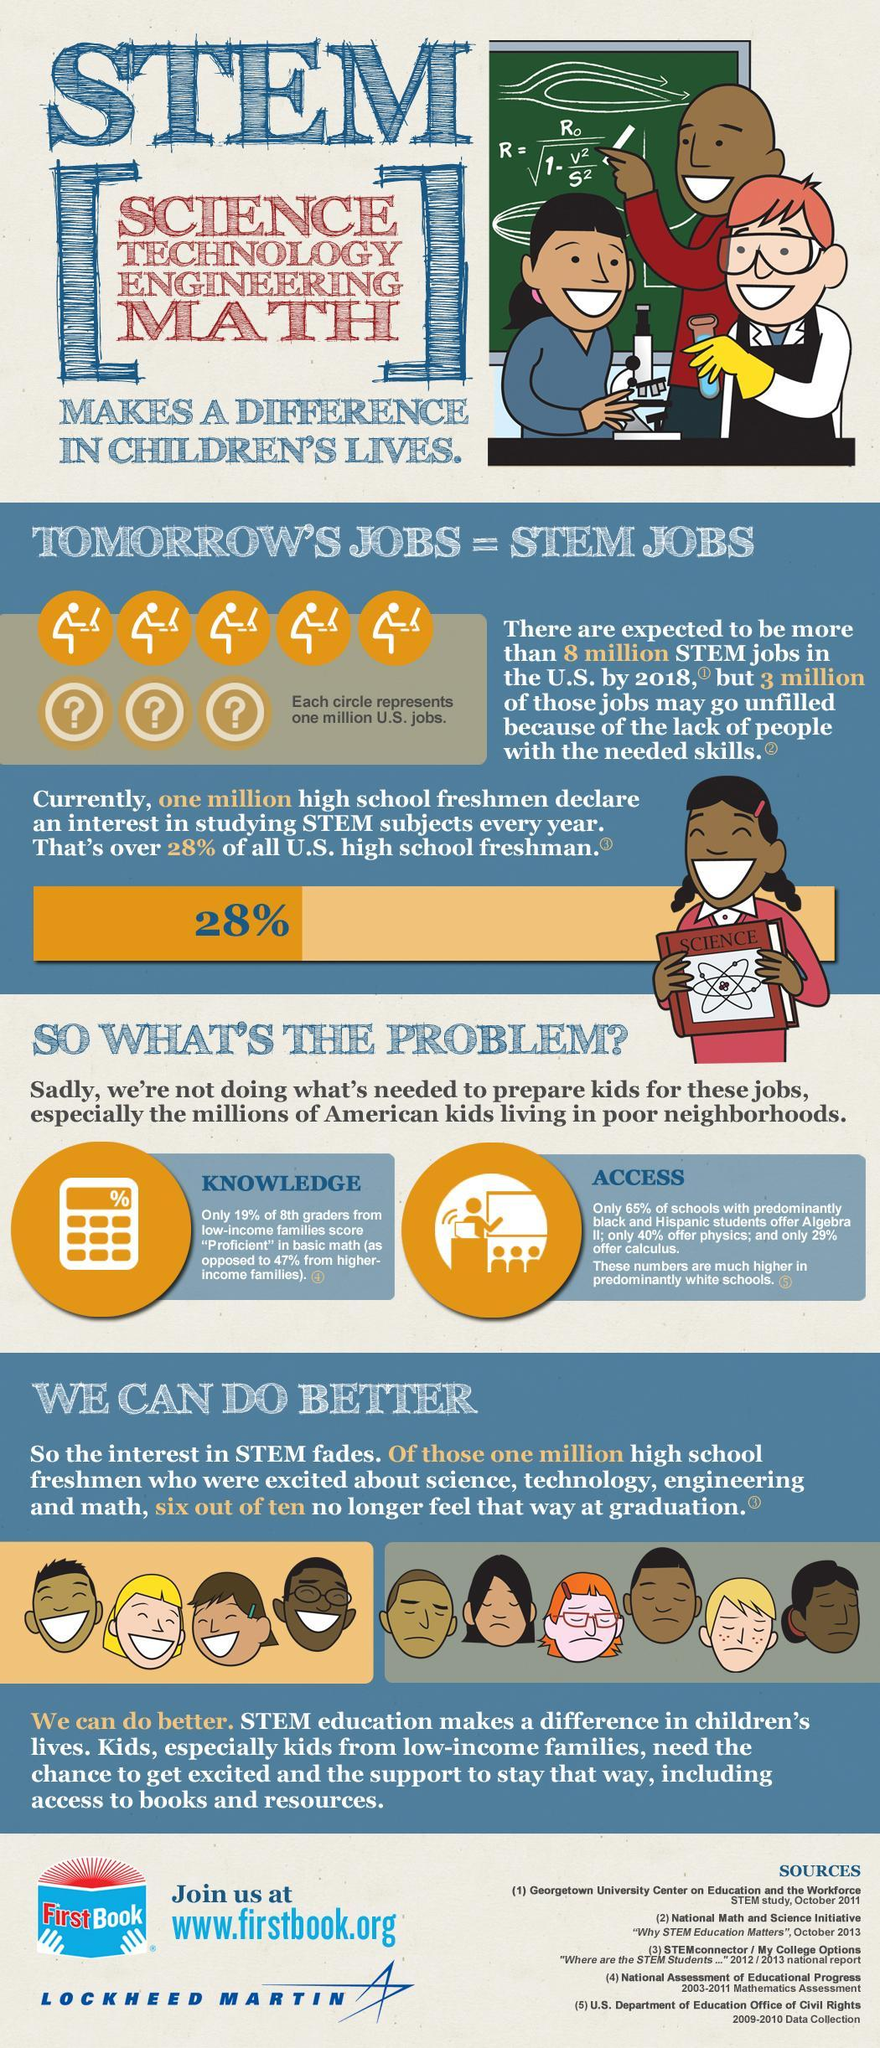What does E in STEM stand for?
Answer the question with a short phrase. Engineering What percent of schools with predominantly black and Hispanic students offer calculus? 29% Among the high school freshmen, how many out of ten remain excited about stem subjects? 4 